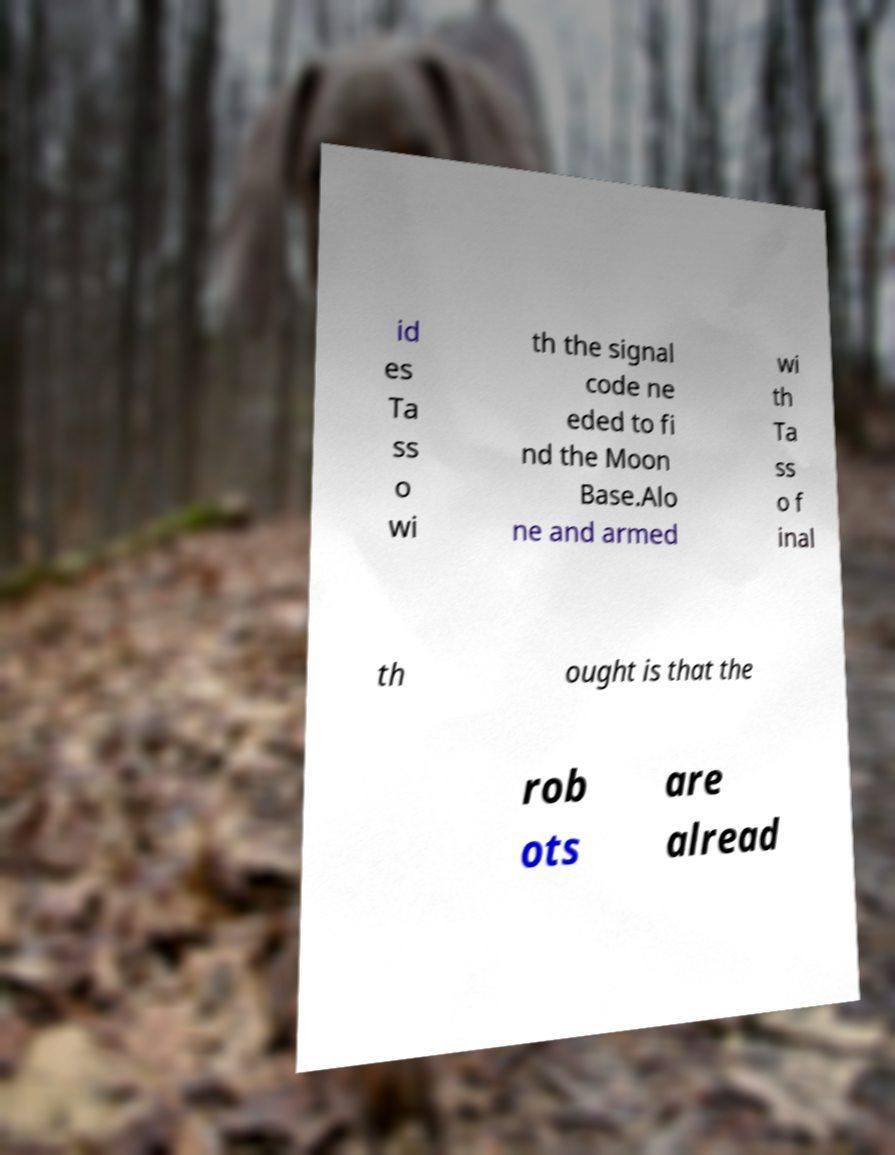Could you extract and type out the text from this image? id es Ta ss o wi th the signal code ne eded to fi nd the Moon Base.Alo ne and armed wi th Ta ss o f inal th ought is that the rob ots are alread 